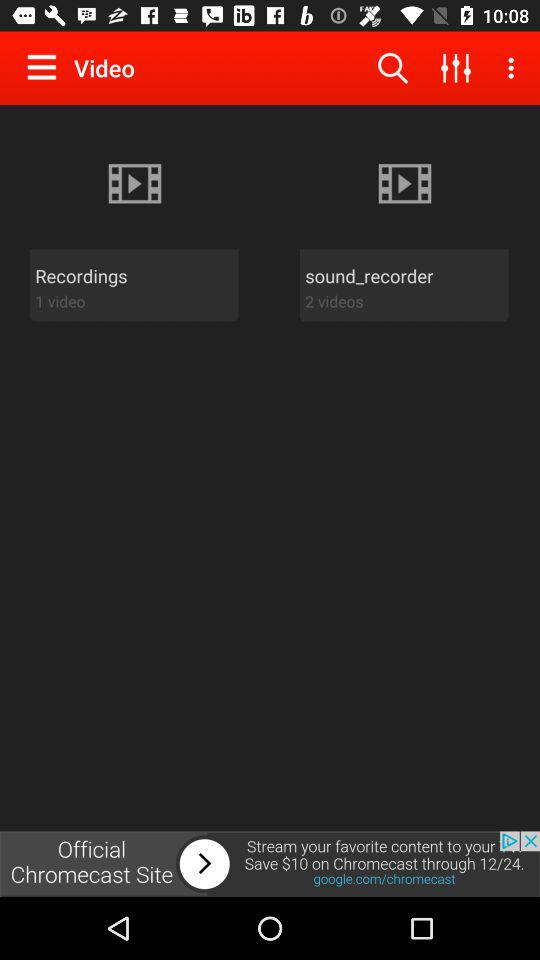Who posted the videos?
When the provided information is insufficient, respond with <no answer>. <no answer> 